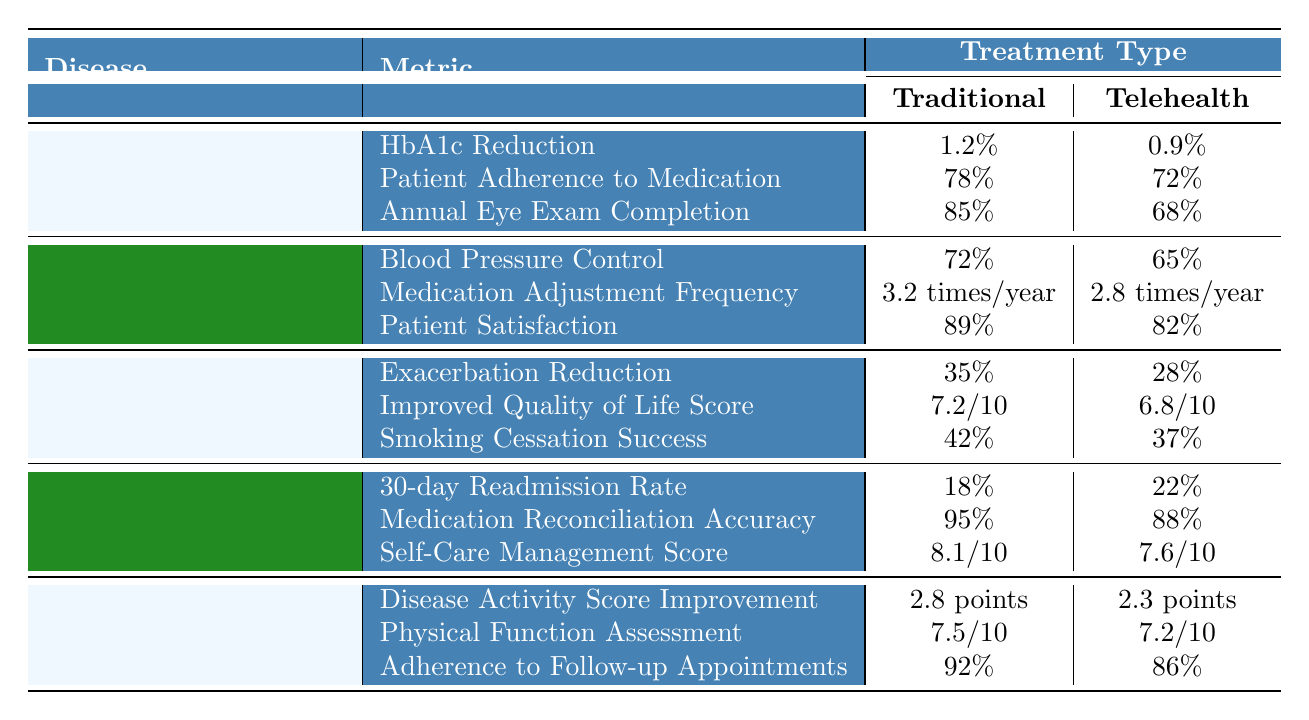What is the HbA1c reduction for traditional treatment in Type 2 Diabetes? The table shows that for Type 2 Diabetes, the HbA1c reduction under traditional treatment is listed as 1.2%.
Answer: 1.2% Which treatment type had a higher patient adherence to medication for Type 2 Diabetes? The table indicates that traditional treatment had a patient adherence to medication of 78%, while telehealth had 72%. Hence, traditional treatment had a higher adherence.
Answer: Traditional treatment What is the difference in annual eye exam completion rates between traditional and telehealth for Type 2 Diabetes? The completion rate for traditional treatment is 85%, while for telehealth, it is 68%. The difference is calculated as 85% - 68% = 17%.
Answer: 17% Is the medication reconciliation accuracy higher for traditional or telehealth in Congestive Heart Failure? The values show traditional treatment has a medication reconciliation accuracy of 95%, while telehealth has 88%. Therefore, traditional treatment is higher.
Answer: Yes, traditional treatment is higher What percentage of patients with Congestive Heart Failure is readmitted within 30 days for telehealth compared to traditional treatment? The table states that the 30-day readmission rate for traditional treatment is 18% and for telehealth is 22%. Thus, telehealth has a higher readmission rate.
Answer: Telehealth has a higher readmission rate Which metric shows a greater improvement for Rheumatoid Arthritis in traditional treatment compared to telehealth? Looking at the disease activity score improvement, traditional treatment shows 2.8 points against telehealth's 2.3 points, which indicates a greater improvement in traditional treatment.
Answer: Disease Activity Score Improvement What is the average score for improved quality of life in COPD for both treatment types? For traditional treatment, the improved quality of life score is 7.2/10, and for telehealth, it is 6.8/10. The average is calculated as (7.2 + 6.8)/2 = 7.0.
Answer: 7.0/10 How does patient satisfaction differ between traditional and telehealth treatments for Hypertension? The table indicates that traditional treatment results in 89% patient satisfaction, compared to 82% for telehealth. Therefore, traditional treatment has better satisfaction.
Answer: Traditional treatment is better Which disease shows the highest reduction of exacerbations with traditional treatment? The highest exacerbation reduction shown is for COPD, with a reduction of 35% for traditional treatment.
Answer: COPD with 35% reduction What percentage increase in smoking cessation success is observed in traditional treatment compared to telehealth for COPD? The traditional smoking cessation success is 42%, while telehealth is 37%. The increase is 42% - 37% = 5%.
Answer: 5% Are patients with Rheumatoid Arthritis more likely to adhere to follow-up appointments with traditional or telehealth treatment? The data shows traditional treatment adherence is at 92%, while telehealth is at 86%. Thus, patients are more likely to adhere to traditional treatment.
Answer: Traditional treatment 